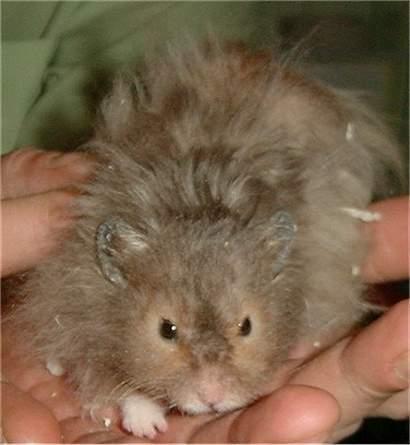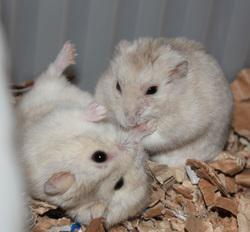The first image is the image on the left, the second image is the image on the right. Analyze the images presented: Is the assertion "at least one hamster in on wood shavings" valid? Answer yes or no. Yes. The first image is the image on the left, the second image is the image on the right. For the images displayed, is the sentence "There are 2 white mice next to each other." factually correct? Answer yes or no. Yes. 